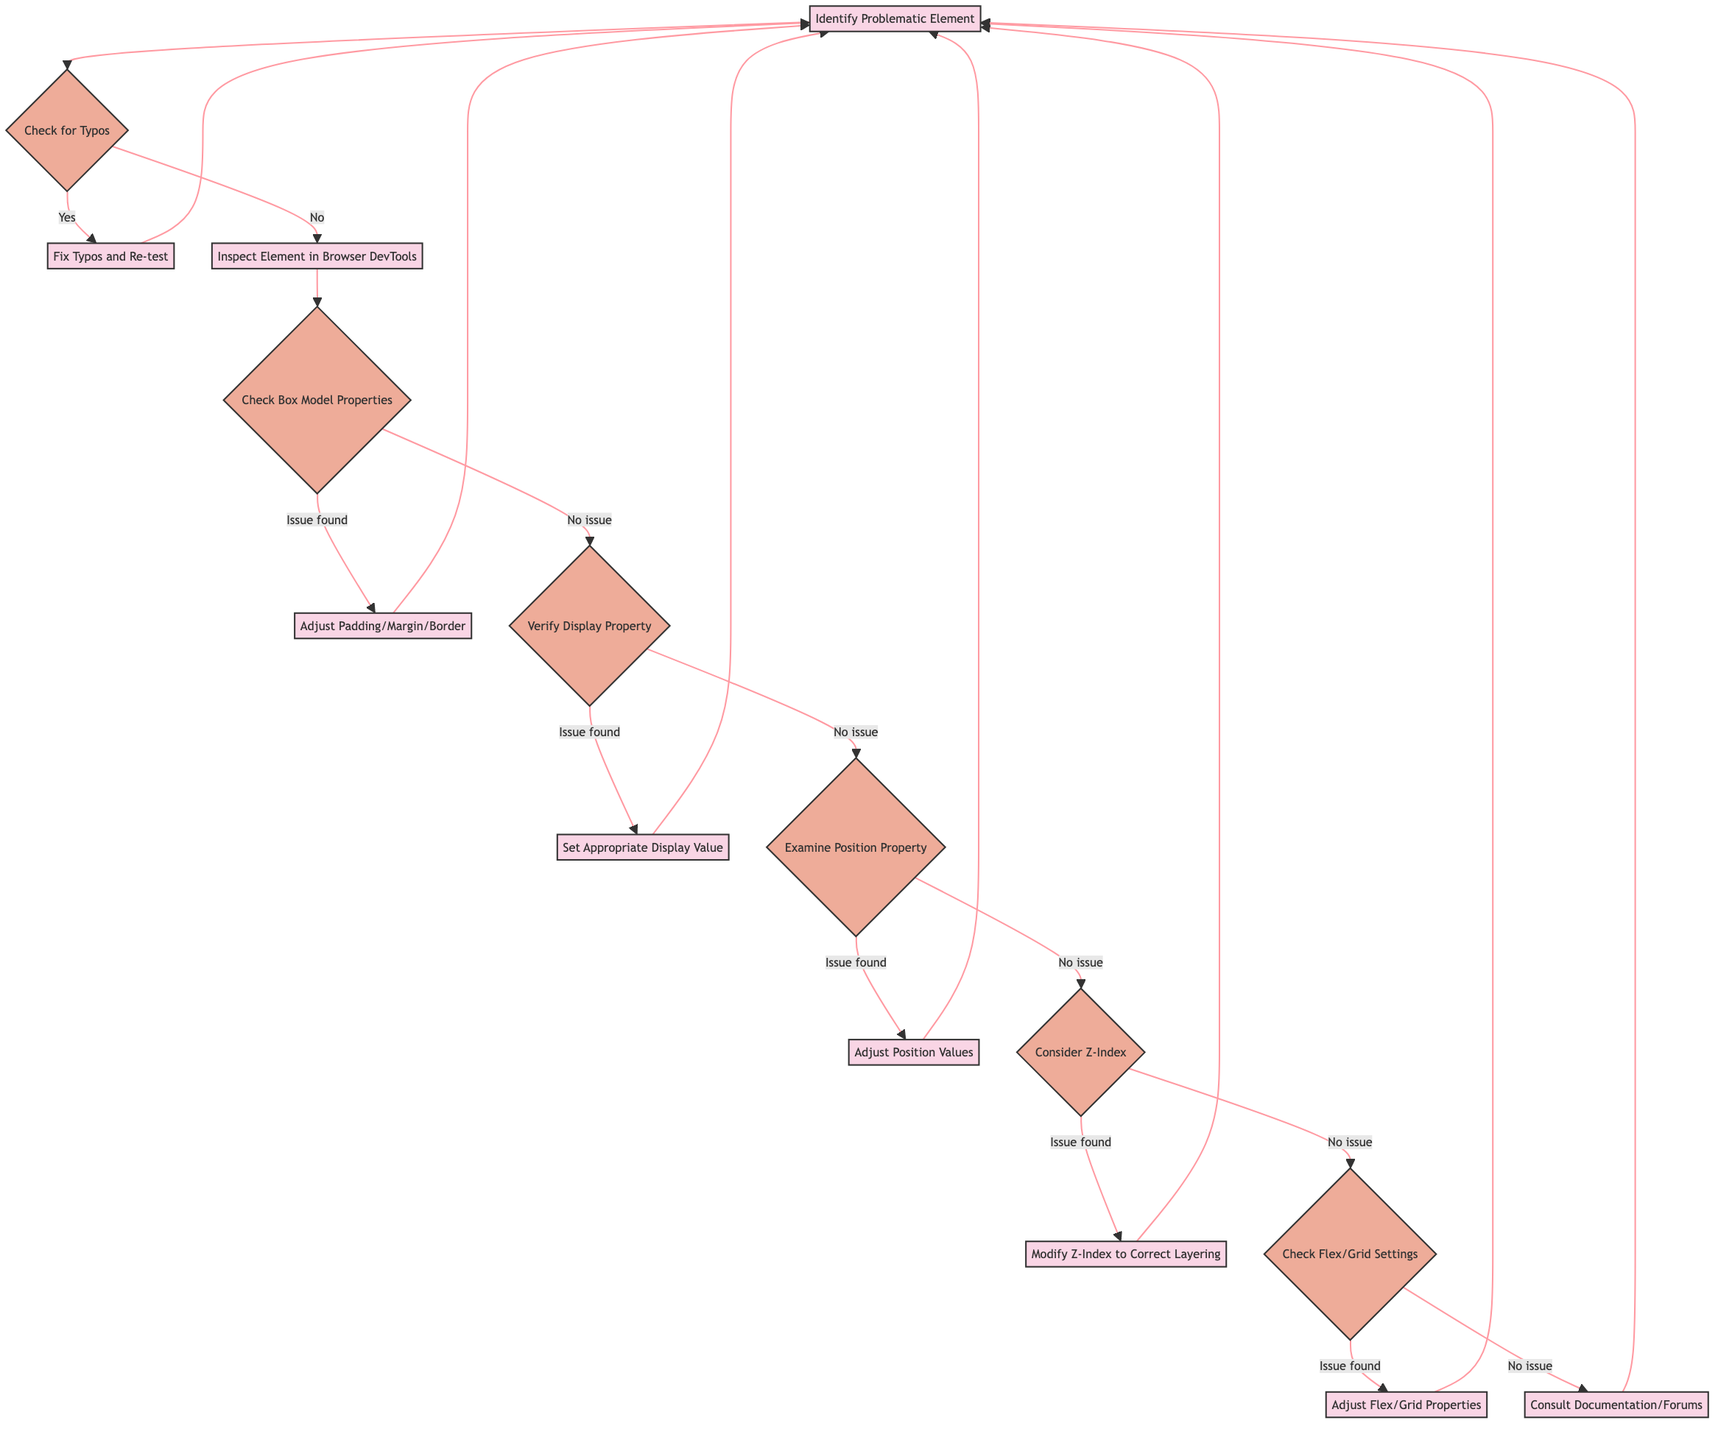What is the first step in the debugging process? The flowchart starts with the first node labeled "Identify Problematic Element," indicating that this is the first step to take in the debugging process.
Answer: Identify Problematic Element How many decision nodes are in the diagram? By counting the decision nodes, we find there are six of them: "Check for Typos," "Check Box Model Properties," "Verify Display Property," "Examine Position Property," "Consider Z-Index," and "Check Flex/Grid Settings."
Answer: Six What action is taken after fixing typos? According to the diagram, after fixing typos, the next action is to "Re-test," which leads back to "Identify Problematic Element."
Answer: Fix Typos and Re-test If the display property is verified and no issue is found, what is the next step? If the display property is verified and no issue is found, the next step is to "Examine Position Property," which is the following decision node after that check.
Answer: Examine Position Property What leads to the decision to consult documentation or forums? The decision to consult documentation or forums occurs when the checks for Z-Index and Flex/Grid settings do not reveal any issues, leading to the last process step "Consult Documentation/Forums" as a last resort.
Answer: Consult Documentation/Forums What will happen if padding, margin, or border adjustments are made? According to the flowchart, if adjustments to padding, margin, or border are made, the process will circle back to the first step "Identify Problematic Element" for further checks.
Answer: Identify Problematic Element What do you check after verifying the display property? After verifying the display property, the next step is to "Examine Position Property" as shown in the diagram flow.
Answer: Examine Position Property What happens if no issues are found in checking box model properties? If no issues are found in checking the box model properties, the process will lead to "Verify Display Property," the next decision point in the flow.
Answer: Verify Display Property What concludes the debugging process in case all checks pass? If all checks pass without issues leading all the way through the flow, it will continue to go back to "Identify Problematic Element," indicating no definitive end point is established in this diagram.
Answer: Identify Problematic Element 